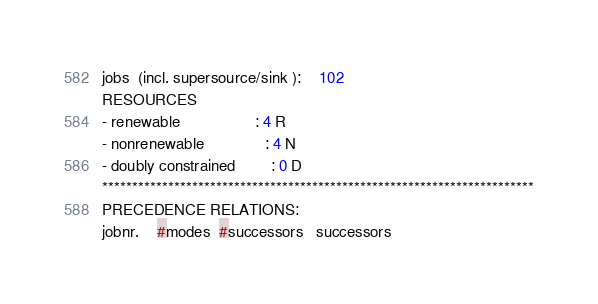<code> <loc_0><loc_0><loc_500><loc_500><_ObjectiveC_>jobs  (incl. supersource/sink ):	102
RESOURCES
- renewable                 : 4 R
- nonrenewable              : 4 N
- doubly constrained        : 0 D
************************************************************************
PRECEDENCE RELATIONS:
jobnr.    #modes  #successors   successors</code> 